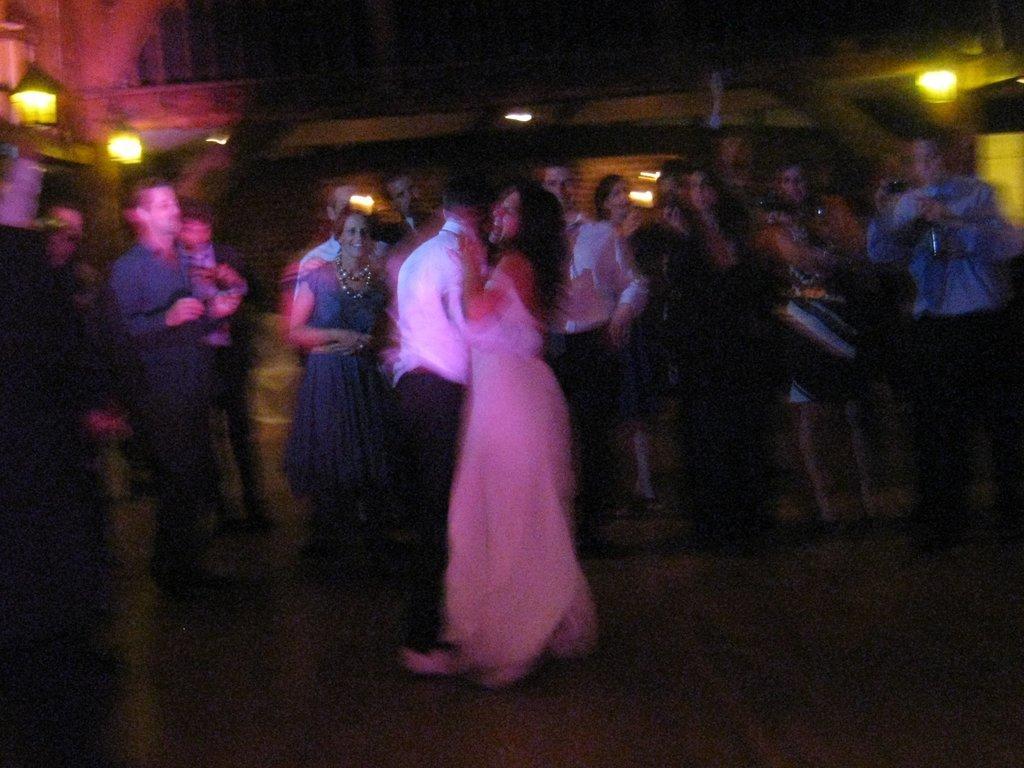Can you describe this image briefly? I can see this is a blur picture. There are group of people standing, there are lights and there are some other objects. 